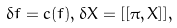<formula> <loc_0><loc_0><loc_500><loc_500>\delta f = c ( f ) , \delta X = [ [ \pi , X ] ] ,</formula> 